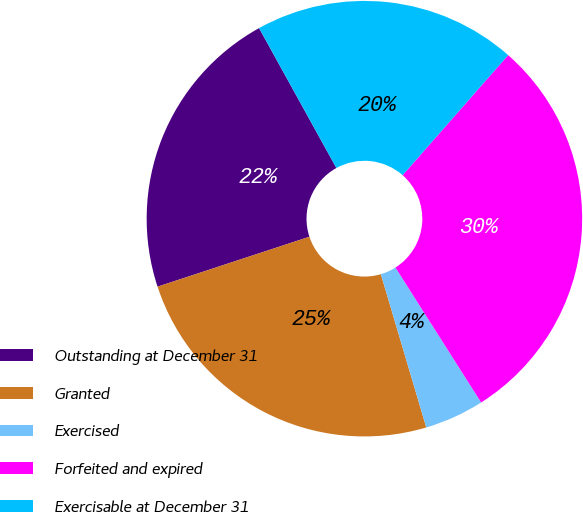Convert chart. <chart><loc_0><loc_0><loc_500><loc_500><pie_chart><fcel>Outstanding at December 31<fcel>Granted<fcel>Exercised<fcel>Forfeited and expired<fcel>Exercisable at December 31<nl><fcel>22.02%<fcel>24.53%<fcel>4.42%<fcel>29.52%<fcel>19.51%<nl></chart> 